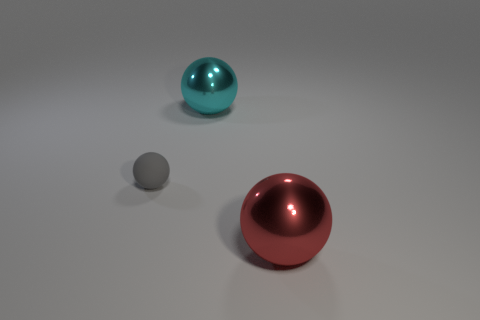Add 3 gray spheres. How many objects exist? 6 Subtract all big metallic balls. How many balls are left? 1 Add 3 big purple rubber blocks. How many big purple rubber blocks exist? 3 Subtract all gray balls. How many balls are left? 2 Subtract 1 gray balls. How many objects are left? 2 Subtract 1 balls. How many balls are left? 2 Subtract all brown spheres. Subtract all cyan blocks. How many spheres are left? 3 Subtract all gray spheres. Subtract all cyan balls. How many objects are left? 1 Add 1 cyan objects. How many cyan objects are left? 2 